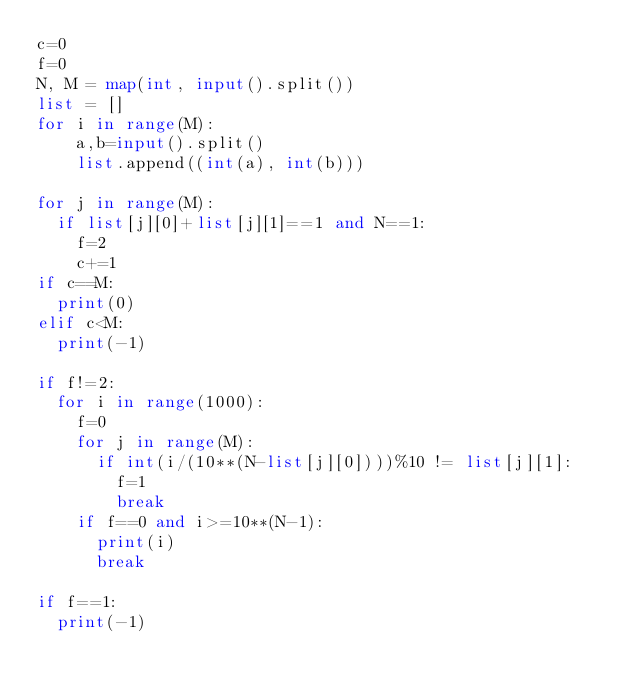Convert code to text. <code><loc_0><loc_0><loc_500><loc_500><_Python_>c=0
f=0
N, M = map(int, input().split())
list = []
for i in range(M):
    a,b=input().split()
    list.append((int(a), int(b)))

for j in range(M):
	if list[j][0]+list[j][1]==1 and N==1:
		f=2
		c+=1
if c==M:
	print(0)
elif c<M:
	print(-1)
			
if f!=2:
	for i in range(1000):
		f=0
		for j in range(M):
			if int(i/(10**(N-list[j][0])))%10 != list[j][1]:
				f=1
				break
		if f==0 and i>=10**(N-1):
			print(i)
			break
		
if f==1:
	print(-1)</code> 